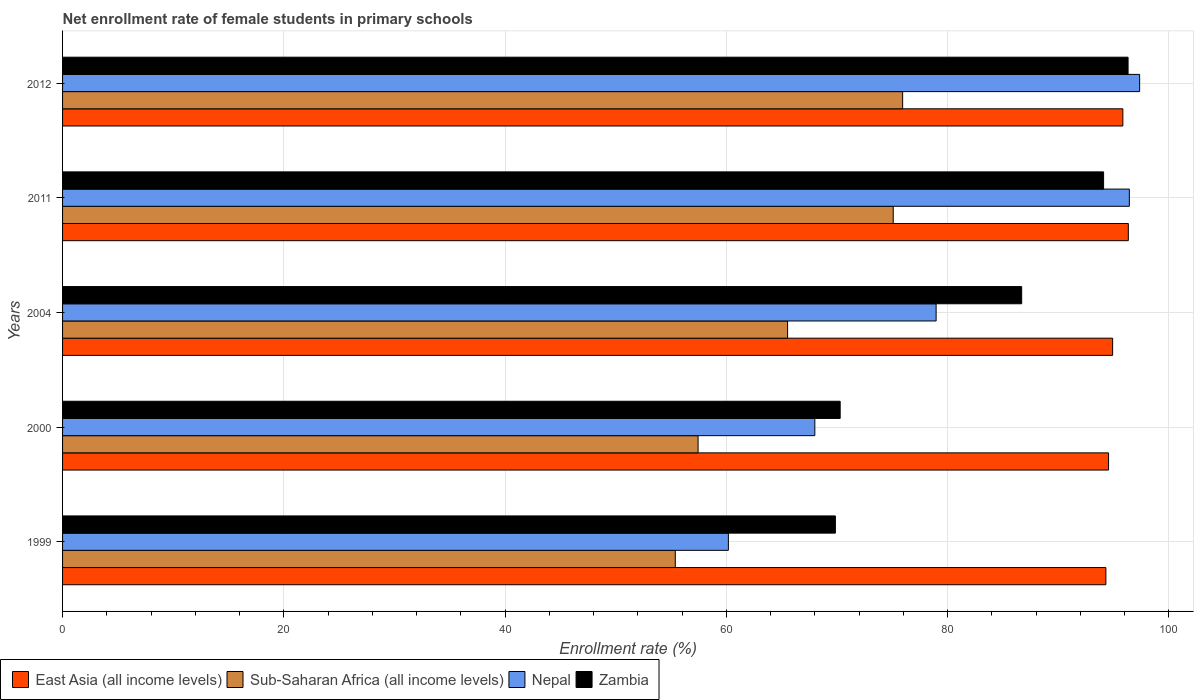How many different coloured bars are there?
Your answer should be compact. 4. How many bars are there on the 1st tick from the top?
Keep it short and to the point. 4. What is the label of the 3rd group of bars from the top?
Give a very brief answer. 2004. What is the net enrollment rate of female students in primary schools in Sub-Saharan Africa (all income levels) in 2000?
Provide a short and direct response. 57.44. Across all years, what is the maximum net enrollment rate of female students in primary schools in Nepal?
Keep it short and to the point. 97.35. Across all years, what is the minimum net enrollment rate of female students in primary schools in Zambia?
Make the answer very short. 69.85. What is the total net enrollment rate of female students in primary schools in Nepal in the graph?
Make the answer very short. 400.9. What is the difference between the net enrollment rate of female students in primary schools in Zambia in 1999 and that in 2012?
Your response must be concise. -26.45. What is the difference between the net enrollment rate of female students in primary schools in Sub-Saharan Africa (all income levels) in 2000 and the net enrollment rate of female students in primary schools in Nepal in 2012?
Keep it short and to the point. -39.91. What is the average net enrollment rate of female students in primary schools in Zambia per year?
Your response must be concise. 83.44. In the year 2000, what is the difference between the net enrollment rate of female students in primary schools in East Asia (all income levels) and net enrollment rate of female students in primary schools in Zambia?
Provide a succinct answer. 24.26. In how many years, is the net enrollment rate of female students in primary schools in Sub-Saharan Africa (all income levels) greater than 16 %?
Your response must be concise. 5. What is the ratio of the net enrollment rate of female students in primary schools in Zambia in 2011 to that in 2012?
Give a very brief answer. 0.98. What is the difference between the highest and the second highest net enrollment rate of female students in primary schools in East Asia (all income levels)?
Ensure brevity in your answer.  0.49. What is the difference between the highest and the lowest net enrollment rate of female students in primary schools in East Asia (all income levels)?
Your answer should be very brief. 2.03. In how many years, is the net enrollment rate of female students in primary schools in Nepal greater than the average net enrollment rate of female students in primary schools in Nepal taken over all years?
Make the answer very short. 2. Is the sum of the net enrollment rate of female students in primary schools in Zambia in 2000 and 2004 greater than the maximum net enrollment rate of female students in primary schools in East Asia (all income levels) across all years?
Your response must be concise. Yes. What does the 1st bar from the top in 1999 represents?
Ensure brevity in your answer.  Zambia. What does the 2nd bar from the bottom in 2012 represents?
Your response must be concise. Sub-Saharan Africa (all income levels). Is it the case that in every year, the sum of the net enrollment rate of female students in primary schools in Sub-Saharan Africa (all income levels) and net enrollment rate of female students in primary schools in Zambia is greater than the net enrollment rate of female students in primary schools in East Asia (all income levels)?
Ensure brevity in your answer.  Yes. What is the difference between two consecutive major ticks on the X-axis?
Your response must be concise. 20. Are the values on the major ticks of X-axis written in scientific E-notation?
Your answer should be compact. No. Does the graph contain any zero values?
Ensure brevity in your answer.  No. What is the title of the graph?
Offer a terse response. Net enrollment rate of female students in primary schools. What is the label or title of the X-axis?
Give a very brief answer. Enrollment rate (%). What is the label or title of the Y-axis?
Offer a very short reply. Years. What is the Enrollment rate (%) of East Asia (all income levels) in 1999?
Ensure brevity in your answer.  94.3. What is the Enrollment rate (%) in Sub-Saharan Africa (all income levels) in 1999?
Offer a very short reply. 55.38. What is the Enrollment rate (%) of Nepal in 1999?
Offer a terse response. 60.18. What is the Enrollment rate (%) in Zambia in 1999?
Your response must be concise. 69.85. What is the Enrollment rate (%) of East Asia (all income levels) in 2000?
Make the answer very short. 94.54. What is the Enrollment rate (%) in Sub-Saharan Africa (all income levels) in 2000?
Provide a short and direct response. 57.44. What is the Enrollment rate (%) in Nepal in 2000?
Provide a short and direct response. 67.99. What is the Enrollment rate (%) in Zambia in 2000?
Your response must be concise. 70.28. What is the Enrollment rate (%) in East Asia (all income levels) in 2004?
Make the answer very short. 94.91. What is the Enrollment rate (%) in Sub-Saharan Africa (all income levels) in 2004?
Offer a terse response. 65.53. What is the Enrollment rate (%) in Nepal in 2004?
Provide a succinct answer. 78.96. What is the Enrollment rate (%) of Zambia in 2004?
Ensure brevity in your answer.  86.69. What is the Enrollment rate (%) of East Asia (all income levels) in 2011?
Your answer should be very brief. 96.33. What is the Enrollment rate (%) of Sub-Saharan Africa (all income levels) in 2011?
Give a very brief answer. 75.08. What is the Enrollment rate (%) in Nepal in 2011?
Your response must be concise. 96.42. What is the Enrollment rate (%) of Zambia in 2011?
Your answer should be compact. 94.09. What is the Enrollment rate (%) in East Asia (all income levels) in 2012?
Provide a short and direct response. 95.83. What is the Enrollment rate (%) in Sub-Saharan Africa (all income levels) in 2012?
Provide a short and direct response. 75.93. What is the Enrollment rate (%) of Nepal in 2012?
Offer a very short reply. 97.35. What is the Enrollment rate (%) in Zambia in 2012?
Offer a very short reply. 96.3. Across all years, what is the maximum Enrollment rate (%) of East Asia (all income levels)?
Ensure brevity in your answer.  96.33. Across all years, what is the maximum Enrollment rate (%) of Sub-Saharan Africa (all income levels)?
Keep it short and to the point. 75.93. Across all years, what is the maximum Enrollment rate (%) in Nepal?
Ensure brevity in your answer.  97.35. Across all years, what is the maximum Enrollment rate (%) of Zambia?
Your response must be concise. 96.3. Across all years, what is the minimum Enrollment rate (%) in East Asia (all income levels)?
Offer a terse response. 94.3. Across all years, what is the minimum Enrollment rate (%) of Sub-Saharan Africa (all income levels)?
Your answer should be very brief. 55.38. Across all years, what is the minimum Enrollment rate (%) of Nepal?
Offer a very short reply. 60.18. Across all years, what is the minimum Enrollment rate (%) in Zambia?
Provide a succinct answer. 69.85. What is the total Enrollment rate (%) in East Asia (all income levels) in the graph?
Offer a very short reply. 475.91. What is the total Enrollment rate (%) of Sub-Saharan Africa (all income levels) in the graph?
Ensure brevity in your answer.  329.36. What is the total Enrollment rate (%) in Nepal in the graph?
Ensure brevity in your answer.  400.9. What is the total Enrollment rate (%) of Zambia in the graph?
Your response must be concise. 417.22. What is the difference between the Enrollment rate (%) in East Asia (all income levels) in 1999 and that in 2000?
Make the answer very short. -0.24. What is the difference between the Enrollment rate (%) in Sub-Saharan Africa (all income levels) in 1999 and that in 2000?
Provide a short and direct response. -2.06. What is the difference between the Enrollment rate (%) of Nepal in 1999 and that in 2000?
Give a very brief answer. -7.81. What is the difference between the Enrollment rate (%) in Zambia in 1999 and that in 2000?
Provide a succinct answer. -0.43. What is the difference between the Enrollment rate (%) in East Asia (all income levels) in 1999 and that in 2004?
Your response must be concise. -0.61. What is the difference between the Enrollment rate (%) in Sub-Saharan Africa (all income levels) in 1999 and that in 2004?
Ensure brevity in your answer.  -10.15. What is the difference between the Enrollment rate (%) of Nepal in 1999 and that in 2004?
Offer a terse response. -18.78. What is the difference between the Enrollment rate (%) in Zambia in 1999 and that in 2004?
Make the answer very short. -16.84. What is the difference between the Enrollment rate (%) of East Asia (all income levels) in 1999 and that in 2011?
Your response must be concise. -2.03. What is the difference between the Enrollment rate (%) in Sub-Saharan Africa (all income levels) in 1999 and that in 2011?
Your answer should be compact. -19.7. What is the difference between the Enrollment rate (%) of Nepal in 1999 and that in 2011?
Your answer should be very brief. -36.24. What is the difference between the Enrollment rate (%) in Zambia in 1999 and that in 2011?
Your response must be concise. -24.24. What is the difference between the Enrollment rate (%) in East Asia (all income levels) in 1999 and that in 2012?
Provide a short and direct response. -1.54. What is the difference between the Enrollment rate (%) in Sub-Saharan Africa (all income levels) in 1999 and that in 2012?
Ensure brevity in your answer.  -20.55. What is the difference between the Enrollment rate (%) in Nepal in 1999 and that in 2012?
Your answer should be very brief. -37.17. What is the difference between the Enrollment rate (%) in Zambia in 1999 and that in 2012?
Your answer should be compact. -26.45. What is the difference between the Enrollment rate (%) in East Asia (all income levels) in 2000 and that in 2004?
Make the answer very short. -0.37. What is the difference between the Enrollment rate (%) of Sub-Saharan Africa (all income levels) in 2000 and that in 2004?
Offer a very short reply. -8.09. What is the difference between the Enrollment rate (%) of Nepal in 2000 and that in 2004?
Keep it short and to the point. -10.96. What is the difference between the Enrollment rate (%) of Zambia in 2000 and that in 2004?
Your answer should be very brief. -16.41. What is the difference between the Enrollment rate (%) of East Asia (all income levels) in 2000 and that in 2011?
Make the answer very short. -1.79. What is the difference between the Enrollment rate (%) in Sub-Saharan Africa (all income levels) in 2000 and that in 2011?
Your answer should be compact. -17.64. What is the difference between the Enrollment rate (%) in Nepal in 2000 and that in 2011?
Your answer should be very brief. -28.43. What is the difference between the Enrollment rate (%) in Zambia in 2000 and that in 2011?
Ensure brevity in your answer.  -23.81. What is the difference between the Enrollment rate (%) of East Asia (all income levels) in 2000 and that in 2012?
Make the answer very short. -1.29. What is the difference between the Enrollment rate (%) of Sub-Saharan Africa (all income levels) in 2000 and that in 2012?
Your answer should be very brief. -18.49. What is the difference between the Enrollment rate (%) of Nepal in 2000 and that in 2012?
Your answer should be very brief. -29.36. What is the difference between the Enrollment rate (%) of Zambia in 2000 and that in 2012?
Keep it short and to the point. -26.02. What is the difference between the Enrollment rate (%) in East Asia (all income levels) in 2004 and that in 2011?
Your answer should be compact. -1.42. What is the difference between the Enrollment rate (%) in Sub-Saharan Africa (all income levels) in 2004 and that in 2011?
Keep it short and to the point. -9.55. What is the difference between the Enrollment rate (%) of Nepal in 2004 and that in 2011?
Your answer should be compact. -17.46. What is the difference between the Enrollment rate (%) in Zambia in 2004 and that in 2011?
Ensure brevity in your answer.  -7.4. What is the difference between the Enrollment rate (%) in East Asia (all income levels) in 2004 and that in 2012?
Offer a terse response. -0.93. What is the difference between the Enrollment rate (%) of Sub-Saharan Africa (all income levels) in 2004 and that in 2012?
Provide a short and direct response. -10.4. What is the difference between the Enrollment rate (%) of Nepal in 2004 and that in 2012?
Make the answer very short. -18.4. What is the difference between the Enrollment rate (%) of Zambia in 2004 and that in 2012?
Keep it short and to the point. -9.62. What is the difference between the Enrollment rate (%) of East Asia (all income levels) in 2011 and that in 2012?
Offer a very short reply. 0.49. What is the difference between the Enrollment rate (%) in Sub-Saharan Africa (all income levels) in 2011 and that in 2012?
Make the answer very short. -0.85. What is the difference between the Enrollment rate (%) of Nepal in 2011 and that in 2012?
Offer a very short reply. -0.93. What is the difference between the Enrollment rate (%) of Zambia in 2011 and that in 2012?
Ensure brevity in your answer.  -2.21. What is the difference between the Enrollment rate (%) of East Asia (all income levels) in 1999 and the Enrollment rate (%) of Sub-Saharan Africa (all income levels) in 2000?
Provide a short and direct response. 36.86. What is the difference between the Enrollment rate (%) of East Asia (all income levels) in 1999 and the Enrollment rate (%) of Nepal in 2000?
Your answer should be very brief. 26.31. What is the difference between the Enrollment rate (%) of East Asia (all income levels) in 1999 and the Enrollment rate (%) of Zambia in 2000?
Your response must be concise. 24.02. What is the difference between the Enrollment rate (%) of Sub-Saharan Africa (all income levels) in 1999 and the Enrollment rate (%) of Nepal in 2000?
Your answer should be compact. -12.61. What is the difference between the Enrollment rate (%) in Sub-Saharan Africa (all income levels) in 1999 and the Enrollment rate (%) in Zambia in 2000?
Your answer should be compact. -14.9. What is the difference between the Enrollment rate (%) in Nepal in 1999 and the Enrollment rate (%) in Zambia in 2000?
Keep it short and to the point. -10.1. What is the difference between the Enrollment rate (%) in East Asia (all income levels) in 1999 and the Enrollment rate (%) in Sub-Saharan Africa (all income levels) in 2004?
Keep it short and to the point. 28.77. What is the difference between the Enrollment rate (%) in East Asia (all income levels) in 1999 and the Enrollment rate (%) in Nepal in 2004?
Provide a short and direct response. 15.34. What is the difference between the Enrollment rate (%) in East Asia (all income levels) in 1999 and the Enrollment rate (%) in Zambia in 2004?
Give a very brief answer. 7.61. What is the difference between the Enrollment rate (%) in Sub-Saharan Africa (all income levels) in 1999 and the Enrollment rate (%) in Nepal in 2004?
Give a very brief answer. -23.58. What is the difference between the Enrollment rate (%) of Sub-Saharan Africa (all income levels) in 1999 and the Enrollment rate (%) of Zambia in 2004?
Offer a terse response. -31.31. What is the difference between the Enrollment rate (%) in Nepal in 1999 and the Enrollment rate (%) in Zambia in 2004?
Provide a short and direct response. -26.51. What is the difference between the Enrollment rate (%) in East Asia (all income levels) in 1999 and the Enrollment rate (%) in Sub-Saharan Africa (all income levels) in 2011?
Give a very brief answer. 19.22. What is the difference between the Enrollment rate (%) of East Asia (all income levels) in 1999 and the Enrollment rate (%) of Nepal in 2011?
Ensure brevity in your answer.  -2.12. What is the difference between the Enrollment rate (%) in East Asia (all income levels) in 1999 and the Enrollment rate (%) in Zambia in 2011?
Your response must be concise. 0.21. What is the difference between the Enrollment rate (%) in Sub-Saharan Africa (all income levels) in 1999 and the Enrollment rate (%) in Nepal in 2011?
Make the answer very short. -41.04. What is the difference between the Enrollment rate (%) of Sub-Saharan Africa (all income levels) in 1999 and the Enrollment rate (%) of Zambia in 2011?
Provide a succinct answer. -38.71. What is the difference between the Enrollment rate (%) in Nepal in 1999 and the Enrollment rate (%) in Zambia in 2011?
Make the answer very short. -33.91. What is the difference between the Enrollment rate (%) in East Asia (all income levels) in 1999 and the Enrollment rate (%) in Sub-Saharan Africa (all income levels) in 2012?
Keep it short and to the point. 18.37. What is the difference between the Enrollment rate (%) in East Asia (all income levels) in 1999 and the Enrollment rate (%) in Nepal in 2012?
Make the answer very short. -3.05. What is the difference between the Enrollment rate (%) in East Asia (all income levels) in 1999 and the Enrollment rate (%) in Zambia in 2012?
Provide a succinct answer. -2.01. What is the difference between the Enrollment rate (%) in Sub-Saharan Africa (all income levels) in 1999 and the Enrollment rate (%) in Nepal in 2012?
Ensure brevity in your answer.  -41.97. What is the difference between the Enrollment rate (%) of Sub-Saharan Africa (all income levels) in 1999 and the Enrollment rate (%) of Zambia in 2012?
Offer a terse response. -40.92. What is the difference between the Enrollment rate (%) of Nepal in 1999 and the Enrollment rate (%) of Zambia in 2012?
Your response must be concise. -36.13. What is the difference between the Enrollment rate (%) of East Asia (all income levels) in 2000 and the Enrollment rate (%) of Sub-Saharan Africa (all income levels) in 2004?
Give a very brief answer. 29.01. What is the difference between the Enrollment rate (%) in East Asia (all income levels) in 2000 and the Enrollment rate (%) in Nepal in 2004?
Offer a terse response. 15.58. What is the difference between the Enrollment rate (%) of East Asia (all income levels) in 2000 and the Enrollment rate (%) of Zambia in 2004?
Offer a terse response. 7.85. What is the difference between the Enrollment rate (%) of Sub-Saharan Africa (all income levels) in 2000 and the Enrollment rate (%) of Nepal in 2004?
Provide a succinct answer. -21.52. What is the difference between the Enrollment rate (%) of Sub-Saharan Africa (all income levels) in 2000 and the Enrollment rate (%) of Zambia in 2004?
Your answer should be very brief. -29.25. What is the difference between the Enrollment rate (%) of Nepal in 2000 and the Enrollment rate (%) of Zambia in 2004?
Your response must be concise. -18.7. What is the difference between the Enrollment rate (%) in East Asia (all income levels) in 2000 and the Enrollment rate (%) in Sub-Saharan Africa (all income levels) in 2011?
Your response must be concise. 19.46. What is the difference between the Enrollment rate (%) of East Asia (all income levels) in 2000 and the Enrollment rate (%) of Nepal in 2011?
Make the answer very short. -1.88. What is the difference between the Enrollment rate (%) in East Asia (all income levels) in 2000 and the Enrollment rate (%) in Zambia in 2011?
Give a very brief answer. 0.45. What is the difference between the Enrollment rate (%) in Sub-Saharan Africa (all income levels) in 2000 and the Enrollment rate (%) in Nepal in 2011?
Provide a succinct answer. -38.98. What is the difference between the Enrollment rate (%) of Sub-Saharan Africa (all income levels) in 2000 and the Enrollment rate (%) of Zambia in 2011?
Provide a succinct answer. -36.65. What is the difference between the Enrollment rate (%) of Nepal in 2000 and the Enrollment rate (%) of Zambia in 2011?
Your response must be concise. -26.1. What is the difference between the Enrollment rate (%) in East Asia (all income levels) in 2000 and the Enrollment rate (%) in Sub-Saharan Africa (all income levels) in 2012?
Your response must be concise. 18.61. What is the difference between the Enrollment rate (%) in East Asia (all income levels) in 2000 and the Enrollment rate (%) in Nepal in 2012?
Provide a short and direct response. -2.81. What is the difference between the Enrollment rate (%) in East Asia (all income levels) in 2000 and the Enrollment rate (%) in Zambia in 2012?
Offer a very short reply. -1.77. What is the difference between the Enrollment rate (%) in Sub-Saharan Africa (all income levels) in 2000 and the Enrollment rate (%) in Nepal in 2012?
Ensure brevity in your answer.  -39.91. What is the difference between the Enrollment rate (%) of Sub-Saharan Africa (all income levels) in 2000 and the Enrollment rate (%) of Zambia in 2012?
Your answer should be compact. -38.87. What is the difference between the Enrollment rate (%) of Nepal in 2000 and the Enrollment rate (%) of Zambia in 2012?
Provide a succinct answer. -28.31. What is the difference between the Enrollment rate (%) in East Asia (all income levels) in 2004 and the Enrollment rate (%) in Sub-Saharan Africa (all income levels) in 2011?
Your answer should be compact. 19.83. What is the difference between the Enrollment rate (%) of East Asia (all income levels) in 2004 and the Enrollment rate (%) of Nepal in 2011?
Your answer should be very brief. -1.51. What is the difference between the Enrollment rate (%) in East Asia (all income levels) in 2004 and the Enrollment rate (%) in Zambia in 2011?
Provide a short and direct response. 0.82. What is the difference between the Enrollment rate (%) in Sub-Saharan Africa (all income levels) in 2004 and the Enrollment rate (%) in Nepal in 2011?
Ensure brevity in your answer.  -30.89. What is the difference between the Enrollment rate (%) of Sub-Saharan Africa (all income levels) in 2004 and the Enrollment rate (%) of Zambia in 2011?
Offer a terse response. -28.56. What is the difference between the Enrollment rate (%) in Nepal in 2004 and the Enrollment rate (%) in Zambia in 2011?
Provide a succinct answer. -15.14. What is the difference between the Enrollment rate (%) of East Asia (all income levels) in 2004 and the Enrollment rate (%) of Sub-Saharan Africa (all income levels) in 2012?
Your response must be concise. 18.98. What is the difference between the Enrollment rate (%) of East Asia (all income levels) in 2004 and the Enrollment rate (%) of Nepal in 2012?
Ensure brevity in your answer.  -2.44. What is the difference between the Enrollment rate (%) of East Asia (all income levels) in 2004 and the Enrollment rate (%) of Zambia in 2012?
Give a very brief answer. -1.4. What is the difference between the Enrollment rate (%) of Sub-Saharan Africa (all income levels) in 2004 and the Enrollment rate (%) of Nepal in 2012?
Your answer should be very brief. -31.82. What is the difference between the Enrollment rate (%) of Sub-Saharan Africa (all income levels) in 2004 and the Enrollment rate (%) of Zambia in 2012?
Your answer should be very brief. -30.77. What is the difference between the Enrollment rate (%) of Nepal in 2004 and the Enrollment rate (%) of Zambia in 2012?
Offer a very short reply. -17.35. What is the difference between the Enrollment rate (%) of East Asia (all income levels) in 2011 and the Enrollment rate (%) of Sub-Saharan Africa (all income levels) in 2012?
Give a very brief answer. 20.4. What is the difference between the Enrollment rate (%) of East Asia (all income levels) in 2011 and the Enrollment rate (%) of Nepal in 2012?
Make the answer very short. -1.02. What is the difference between the Enrollment rate (%) of East Asia (all income levels) in 2011 and the Enrollment rate (%) of Zambia in 2012?
Give a very brief answer. 0.02. What is the difference between the Enrollment rate (%) of Sub-Saharan Africa (all income levels) in 2011 and the Enrollment rate (%) of Nepal in 2012?
Offer a very short reply. -22.27. What is the difference between the Enrollment rate (%) in Sub-Saharan Africa (all income levels) in 2011 and the Enrollment rate (%) in Zambia in 2012?
Offer a very short reply. -21.23. What is the difference between the Enrollment rate (%) of Nepal in 2011 and the Enrollment rate (%) of Zambia in 2012?
Provide a succinct answer. 0.12. What is the average Enrollment rate (%) of East Asia (all income levels) per year?
Your answer should be compact. 95.18. What is the average Enrollment rate (%) in Sub-Saharan Africa (all income levels) per year?
Ensure brevity in your answer.  65.87. What is the average Enrollment rate (%) in Nepal per year?
Ensure brevity in your answer.  80.18. What is the average Enrollment rate (%) in Zambia per year?
Your answer should be compact. 83.44. In the year 1999, what is the difference between the Enrollment rate (%) of East Asia (all income levels) and Enrollment rate (%) of Sub-Saharan Africa (all income levels)?
Your answer should be very brief. 38.92. In the year 1999, what is the difference between the Enrollment rate (%) in East Asia (all income levels) and Enrollment rate (%) in Nepal?
Keep it short and to the point. 34.12. In the year 1999, what is the difference between the Enrollment rate (%) in East Asia (all income levels) and Enrollment rate (%) in Zambia?
Offer a very short reply. 24.45. In the year 1999, what is the difference between the Enrollment rate (%) in Sub-Saharan Africa (all income levels) and Enrollment rate (%) in Nepal?
Keep it short and to the point. -4.8. In the year 1999, what is the difference between the Enrollment rate (%) of Sub-Saharan Africa (all income levels) and Enrollment rate (%) of Zambia?
Give a very brief answer. -14.47. In the year 1999, what is the difference between the Enrollment rate (%) of Nepal and Enrollment rate (%) of Zambia?
Make the answer very short. -9.67. In the year 2000, what is the difference between the Enrollment rate (%) of East Asia (all income levels) and Enrollment rate (%) of Sub-Saharan Africa (all income levels)?
Make the answer very short. 37.1. In the year 2000, what is the difference between the Enrollment rate (%) in East Asia (all income levels) and Enrollment rate (%) in Nepal?
Keep it short and to the point. 26.55. In the year 2000, what is the difference between the Enrollment rate (%) of East Asia (all income levels) and Enrollment rate (%) of Zambia?
Your answer should be compact. 24.26. In the year 2000, what is the difference between the Enrollment rate (%) of Sub-Saharan Africa (all income levels) and Enrollment rate (%) of Nepal?
Ensure brevity in your answer.  -10.55. In the year 2000, what is the difference between the Enrollment rate (%) of Sub-Saharan Africa (all income levels) and Enrollment rate (%) of Zambia?
Ensure brevity in your answer.  -12.84. In the year 2000, what is the difference between the Enrollment rate (%) in Nepal and Enrollment rate (%) in Zambia?
Keep it short and to the point. -2.29. In the year 2004, what is the difference between the Enrollment rate (%) of East Asia (all income levels) and Enrollment rate (%) of Sub-Saharan Africa (all income levels)?
Keep it short and to the point. 29.38. In the year 2004, what is the difference between the Enrollment rate (%) of East Asia (all income levels) and Enrollment rate (%) of Nepal?
Your answer should be very brief. 15.95. In the year 2004, what is the difference between the Enrollment rate (%) in East Asia (all income levels) and Enrollment rate (%) in Zambia?
Ensure brevity in your answer.  8.22. In the year 2004, what is the difference between the Enrollment rate (%) of Sub-Saharan Africa (all income levels) and Enrollment rate (%) of Nepal?
Give a very brief answer. -13.42. In the year 2004, what is the difference between the Enrollment rate (%) in Sub-Saharan Africa (all income levels) and Enrollment rate (%) in Zambia?
Provide a succinct answer. -21.16. In the year 2004, what is the difference between the Enrollment rate (%) of Nepal and Enrollment rate (%) of Zambia?
Your answer should be very brief. -7.73. In the year 2011, what is the difference between the Enrollment rate (%) of East Asia (all income levels) and Enrollment rate (%) of Sub-Saharan Africa (all income levels)?
Make the answer very short. 21.25. In the year 2011, what is the difference between the Enrollment rate (%) of East Asia (all income levels) and Enrollment rate (%) of Nepal?
Your answer should be compact. -0.09. In the year 2011, what is the difference between the Enrollment rate (%) in East Asia (all income levels) and Enrollment rate (%) in Zambia?
Your answer should be compact. 2.24. In the year 2011, what is the difference between the Enrollment rate (%) in Sub-Saharan Africa (all income levels) and Enrollment rate (%) in Nepal?
Your answer should be very brief. -21.34. In the year 2011, what is the difference between the Enrollment rate (%) of Sub-Saharan Africa (all income levels) and Enrollment rate (%) of Zambia?
Make the answer very short. -19.02. In the year 2011, what is the difference between the Enrollment rate (%) in Nepal and Enrollment rate (%) in Zambia?
Your answer should be very brief. 2.33. In the year 2012, what is the difference between the Enrollment rate (%) of East Asia (all income levels) and Enrollment rate (%) of Sub-Saharan Africa (all income levels)?
Provide a short and direct response. 19.9. In the year 2012, what is the difference between the Enrollment rate (%) of East Asia (all income levels) and Enrollment rate (%) of Nepal?
Keep it short and to the point. -1.52. In the year 2012, what is the difference between the Enrollment rate (%) in East Asia (all income levels) and Enrollment rate (%) in Zambia?
Give a very brief answer. -0.47. In the year 2012, what is the difference between the Enrollment rate (%) in Sub-Saharan Africa (all income levels) and Enrollment rate (%) in Nepal?
Your response must be concise. -21.42. In the year 2012, what is the difference between the Enrollment rate (%) of Sub-Saharan Africa (all income levels) and Enrollment rate (%) of Zambia?
Give a very brief answer. -20.37. In the year 2012, what is the difference between the Enrollment rate (%) in Nepal and Enrollment rate (%) in Zambia?
Your answer should be compact. 1.05. What is the ratio of the Enrollment rate (%) in East Asia (all income levels) in 1999 to that in 2000?
Your answer should be very brief. 1. What is the ratio of the Enrollment rate (%) in Sub-Saharan Africa (all income levels) in 1999 to that in 2000?
Make the answer very short. 0.96. What is the ratio of the Enrollment rate (%) of Nepal in 1999 to that in 2000?
Offer a very short reply. 0.89. What is the ratio of the Enrollment rate (%) of East Asia (all income levels) in 1999 to that in 2004?
Make the answer very short. 0.99. What is the ratio of the Enrollment rate (%) in Sub-Saharan Africa (all income levels) in 1999 to that in 2004?
Your response must be concise. 0.85. What is the ratio of the Enrollment rate (%) of Nepal in 1999 to that in 2004?
Keep it short and to the point. 0.76. What is the ratio of the Enrollment rate (%) in Zambia in 1999 to that in 2004?
Keep it short and to the point. 0.81. What is the ratio of the Enrollment rate (%) of East Asia (all income levels) in 1999 to that in 2011?
Provide a succinct answer. 0.98. What is the ratio of the Enrollment rate (%) of Sub-Saharan Africa (all income levels) in 1999 to that in 2011?
Your answer should be compact. 0.74. What is the ratio of the Enrollment rate (%) in Nepal in 1999 to that in 2011?
Your answer should be compact. 0.62. What is the ratio of the Enrollment rate (%) in Zambia in 1999 to that in 2011?
Ensure brevity in your answer.  0.74. What is the ratio of the Enrollment rate (%) of Sub-Saharan Africa (all income levels) in 1999 to that in 2012?
Your response must be concise. 0.73. What is the ratio of the Enrollment rate (%) in Nepal in 1999 to that in 2012?
Your answer should be compact. 0.62. What is the ratio of the Enrollment rate (%) of Zambia in 1999 to that in 2012?
Provide a succinct answer. 0.73. What is the ratio of the Enrollment rate (%) in Sub-Saharan Africa (all income levels) in 2000 to that in 2004?
Make the answer very short. 0.88. What is the ratio of the Enrollment rate (%) in Nepal in 2000 to that in 2004?
Your answer should be very brief. 0.86. What is the ratio of the Enrollment rate (%) in Zambia in 2000 to that in 2004?
Keep it short and to the point. 0.81. What is the ratio of the Enrollment rate (%) of East Asia (all income levels) in 2000 to that in 2011?
Offer a very short reply. 0.98. What is the ratio of the Enrollment rate (%) in Sub-Saharan Africa (all income levels) in 2000 to that in 2011?
Your answer should be very brief. 0.77. What is the ratio of the Enrollment rate (%) in Nepal in 2000 to that in 2011?
Your response must be concise. 0.71. What is the ratio of the Enrollment rate (%) in Zambia in 2000 to that in 2011?
Offer a terse response. 0.75. What is the ratio of the Enrollment rate (%) in East Asia (all income levels) in 2000 to that in 2012?
Offer a terse response. 0.99. What is the ratio of the Enrollment rate (%) of Sub-Saharan Africa (all income levels) in 2000 to that in 2012?
Make the answer very short. 0.76. What is the ratio of the Enrollment rate (%) of Nepal in 2000 to that in 2012?
Offer a terse response. 0.7. What is the ratio of the Enrollment rate (%) in Zambia in 2000 to that in 2012?
Provide a succinct answer. 0.73. What is the ratio of the Enrollment rate (%) of Sub-Saharan Africa (all income levels) in 2004 to that in 2011?
Provide a succinct answer. 0.87. What is the ratio of the Enrollment rate (%) of Nepal in 2004 to that in 2011?
Your answer should be very brief. 0.82. What is the ratio of the Enrollment rate (%) of Zambia in 2004 to that in 2011?
Offer a terse response. 0.92. What is the ratio of the Enrollment rate (%) in East Asia (all income levels) in 2004 to that in 2012?
Offer a terse response. 0.99. What is the ratio of the Enrollment rate (%) in Sub-Saharan Africa (all income levels) in 2004 to that in 2012?
Give a very brief answer. 0.86. What is the ratio of the Enrollment rate (%) of Nepal in 2004 to that in 2012?
Keep it short and to the point. 0.81. What is the ratio of the Enrollment rate (%) in Zambia in 2004 to that in 2012?
Your response must be concise. 0.9. What is the ratio of the Enrollment rate (%) in Sub-Saharan Africa (all income levels) in 2011 to that in 2012?
Provide a succinct answer. 0.99. What is the difference between the highest and the second highest Enrollment rate (%) of East Asia (all income levels)?
Your answer should be very brief. 0.49. What is the difference between the highest and the second highest Enrollment rate (%) in Sub-Saharan Africa (all income levels)?
Ensure brevity in your answer.  0.85. What is the difference between the highest and the second highest Enrollment rate (%) of Zambia?
Provide a succinct answer. 2.21. What is the difference between the highest and the lowest Enrollment rate (%) of East Asia (all income levels)?
Make the answer very short. 2.03. What is the difference between the highest and the lowest Enrollment rate (%) of Sub-Saharan Africa (all income levels)?
Your response must be concise. 20.55. What is the difference between the highest and the lowest Enrollment rate (%) in Nepal?
Your answer should be very brief. 37.17. What is the difference between the highest and the lowest Enrollment rate (%) of Zambia?
Offer a terse response. 26.45. 